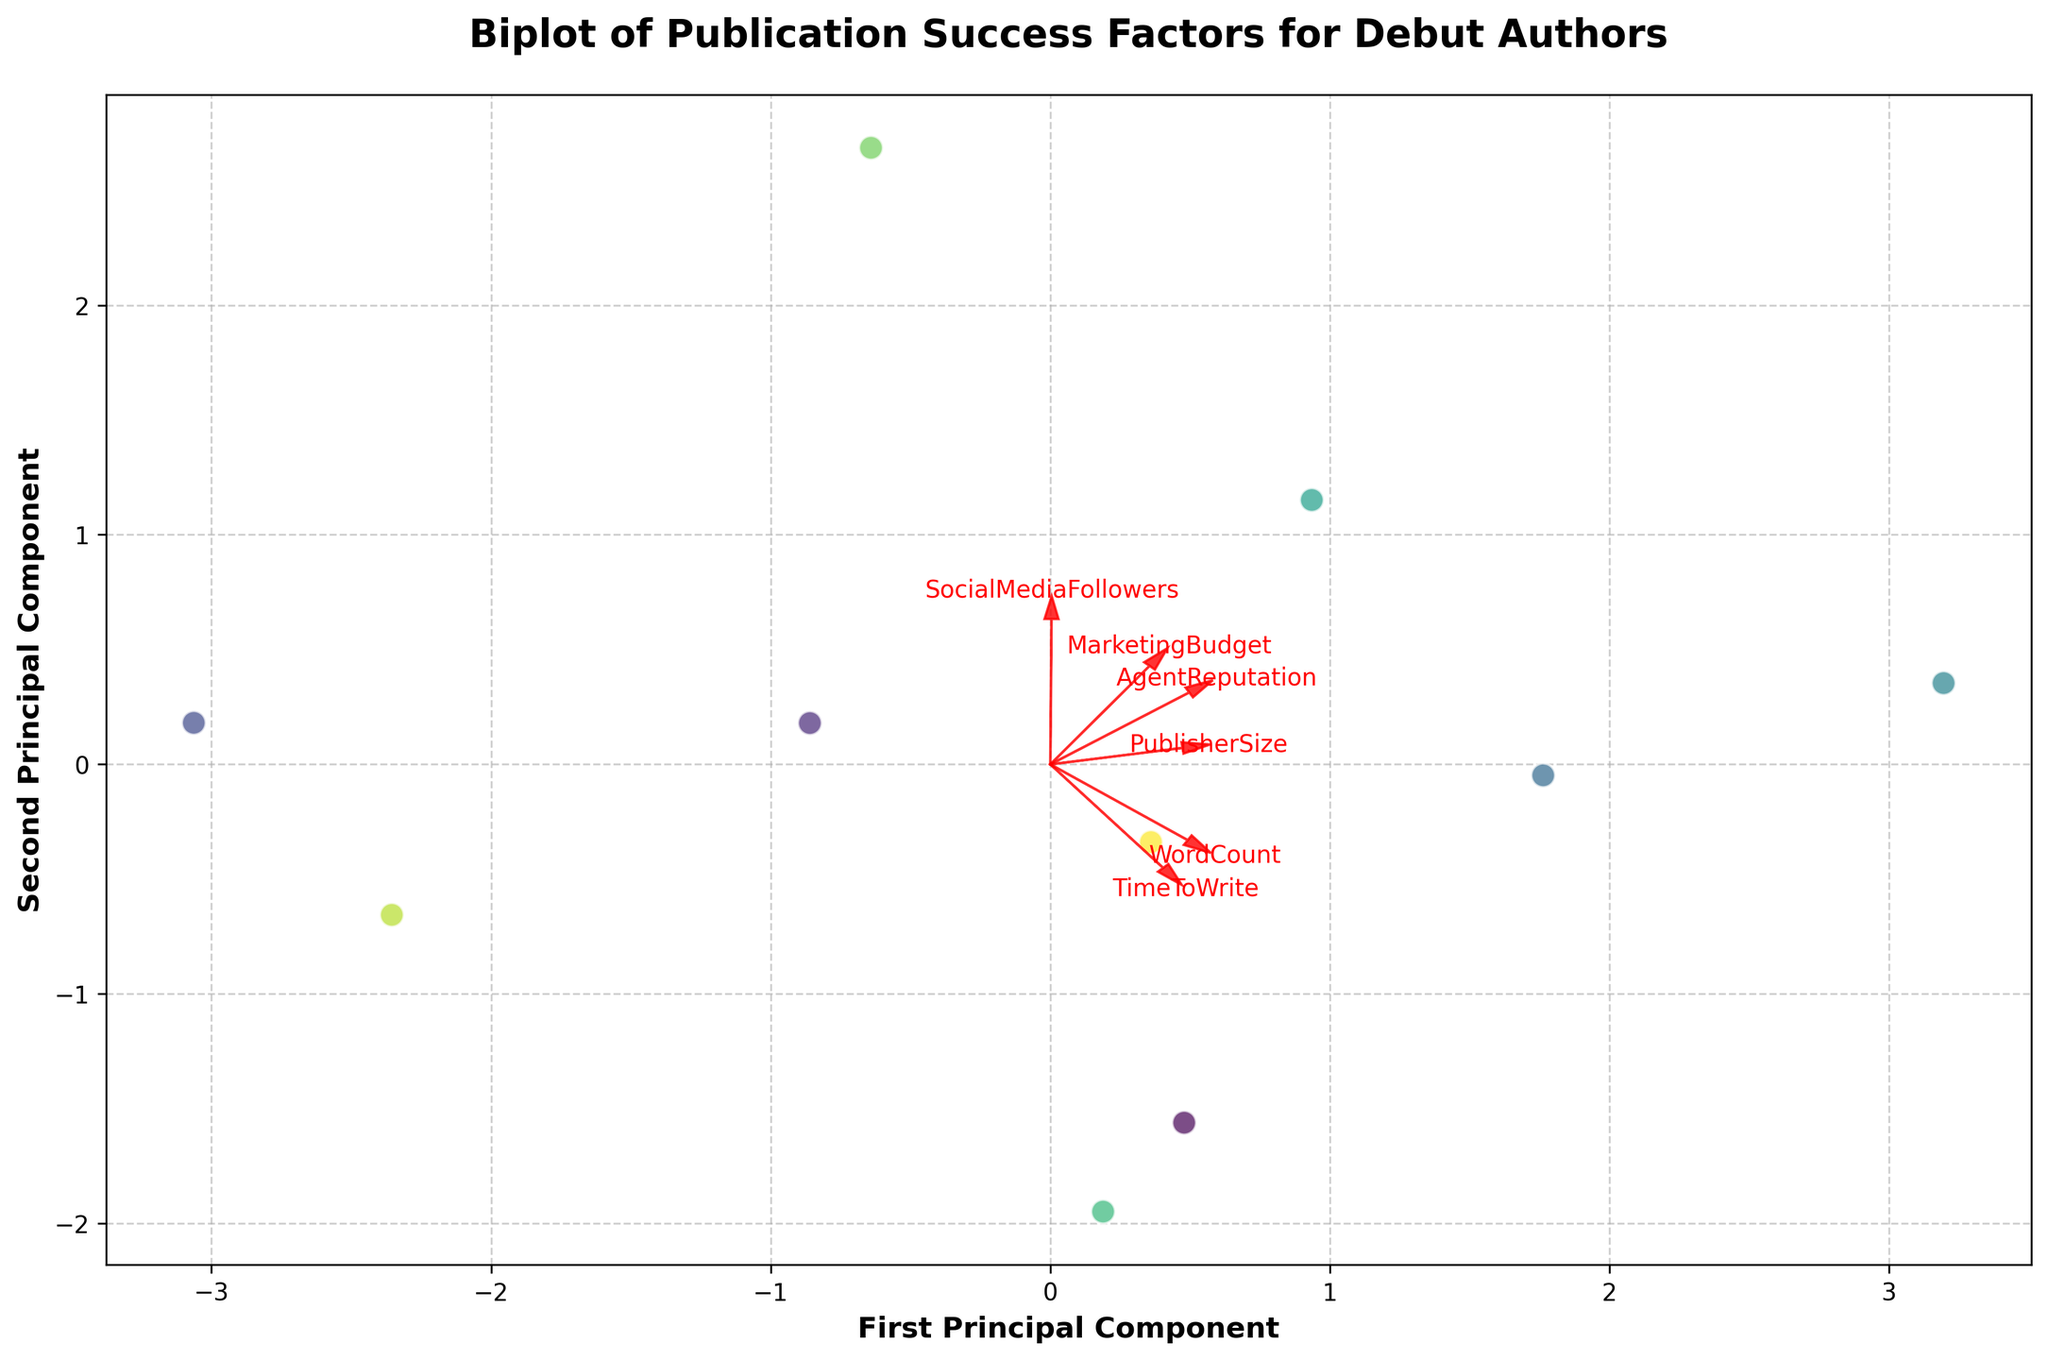What is the title of the biplot? The title of the plot is written at the top of the figure, which is "Biplot of Publication Success Factors for Debut Authors."
Answer: Biplot of Publication Success Factors for Debut Authors How many literary genres are represented in the biplot? Each genre is represented by a different color and is listed in the legend. There are 10 colors in the legend corresponding to 10 different genres.
Answer: 10 Which two genres are closest to each other on the biplot? The positions of the data points on the plot indicate the distances between them. The two genres that appear closest together can be identified visually.
Answer: Mystery and Thriller Which feature vectors have larger magnitudes compared to others? The lengths of the arrows represent the magnitude of the feature vectors. By comparing the lengths, we can identify the features with the longest arrows.
Answer: SocialMediaFollowers and TimeToWrite Which genre has the highest principal component 1 (PC1) value? The positions of data points along the x-axis (PC1) show the PC1 values. The genre with the farthest right position on the x-axis has the highest PC1 value.
Answer: Fantasy Do any genres overlap in the biplot? Overlapping data points can be seen visually. Identify if any genre points are placed in exactly the same or very close positions.
Answer: No How many feature vectors have positive values for both principal components? The directions of the arrows indicate the values of the principal components. Count the arrows pointing into the positive quadrant of both PC1 (x-axis) and PC2 (y-axis).
Answer: 4 Which two features have the most similar directions in the biplot? The direction of the arrows indicates the orientation of the features. Features with arrows pointing in similar directions are the ones that are most similar.
Answer: MarketingBudget and TimeToWrite Which genre is associated with high social media followers based on the biplot? The position of the genres relative to the SocialMediaFollowers arrow indicates their association. The genre closest in the direction of this arrow has high social media followers.
Answer: Young Adult Does WordCount have a strong influence on either of the first two principal components? The length and direction of the WordCount arrow indicate its influence on the principal components. A longer arrow would indicate a strong influence.
Answer: Yes, a moderate influence 